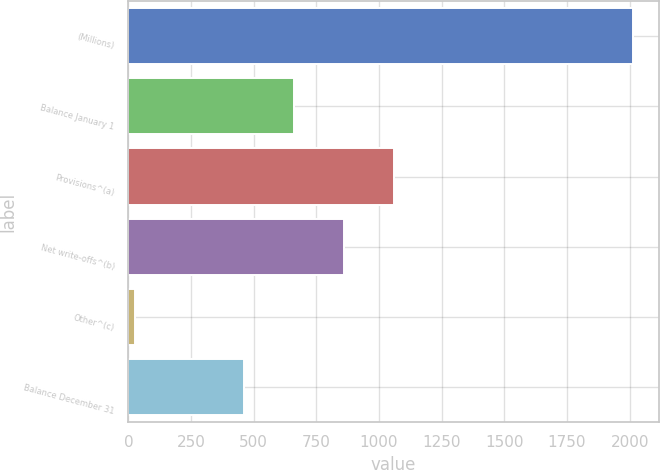Convert chart. <chart><loc_0><loc_0><loc_500><loc_500><bar_chart><fcel>(Millions)<fcel>Balance January 1<fcel>Provisions^(a)<fcel>Net write-offs^(b)<fcel>Other^(c)<fcel>Balance December 31<nl><fcel>2015<fcel>660.8<fcel>1058.4<fcel>859.6<fcel>27<fcel>462<nl></chart> 